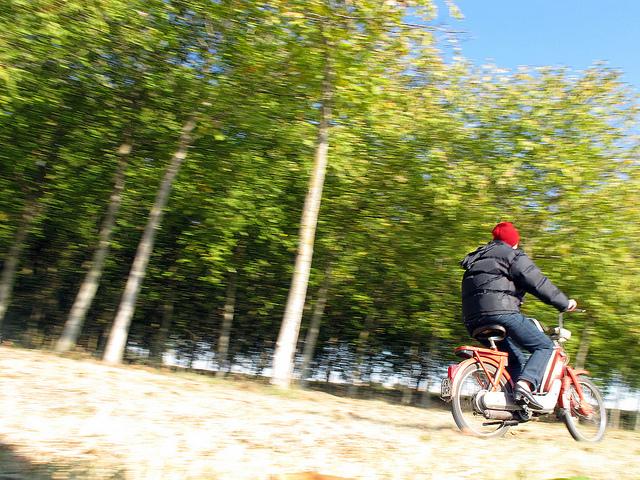What color is the man's hat?
Concise answer only. Red. What is the man riding?
Keep it brief. Bike. Is the man being safe?
Keep it brief. No. 